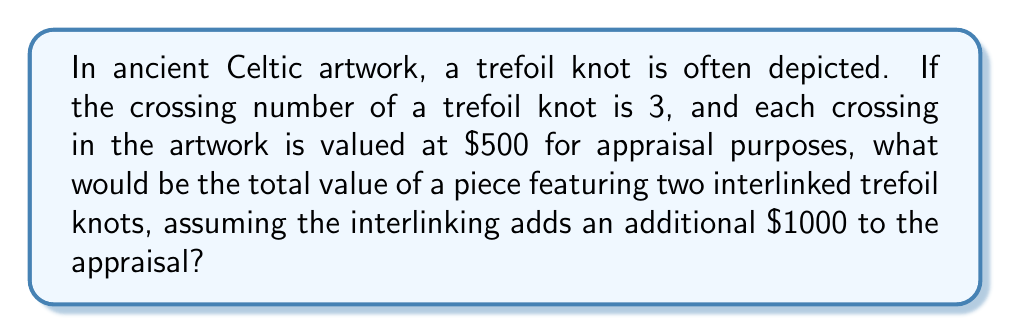Give your solution to this math problem. Let's break this down step-by-step:

1) First, recall that a trefoil knot has a crossing number of 3. This means it has 3 crossings.

2) Each crossing is valued at $\$500$ for appraisal purposes.

3) For a single trefoil knot, the value would be:
   $$3 \times \$500 = \$1500$$

4) We have two interlinked trefoil knots, so we need to double this:
   $$2 \times \$1500 = \$3000$$

5) The interlinking of the two knots adds an additional $\$1000$ to the appraisal.

6) Therefore, the total value is:
   $$\$3000 + \$1000 = \$4000$$

This calculation gives us the total appraised value of the Celtic artwork featuring two interlinked trefoil knots.
Answer: $\$4000$ 